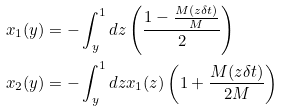Convert formula to latex. <formula><loc_0><loc_0><loc_500><loc_500>x _ { 1 } ( y ) & = - \int _ { y } ^ { 1 } d z \left ( \frac { 1 - \frac { M ( z \delta t ) } { M } } { 2 } \right ) \\ x _ { 2 } ( y ) & = - \int _ { y } ^ { 1 } d z x _ { 1 } ( z ) \left ( 1 + \frac { M ( z \delta t ) } { 2 M } \right )</formula> 